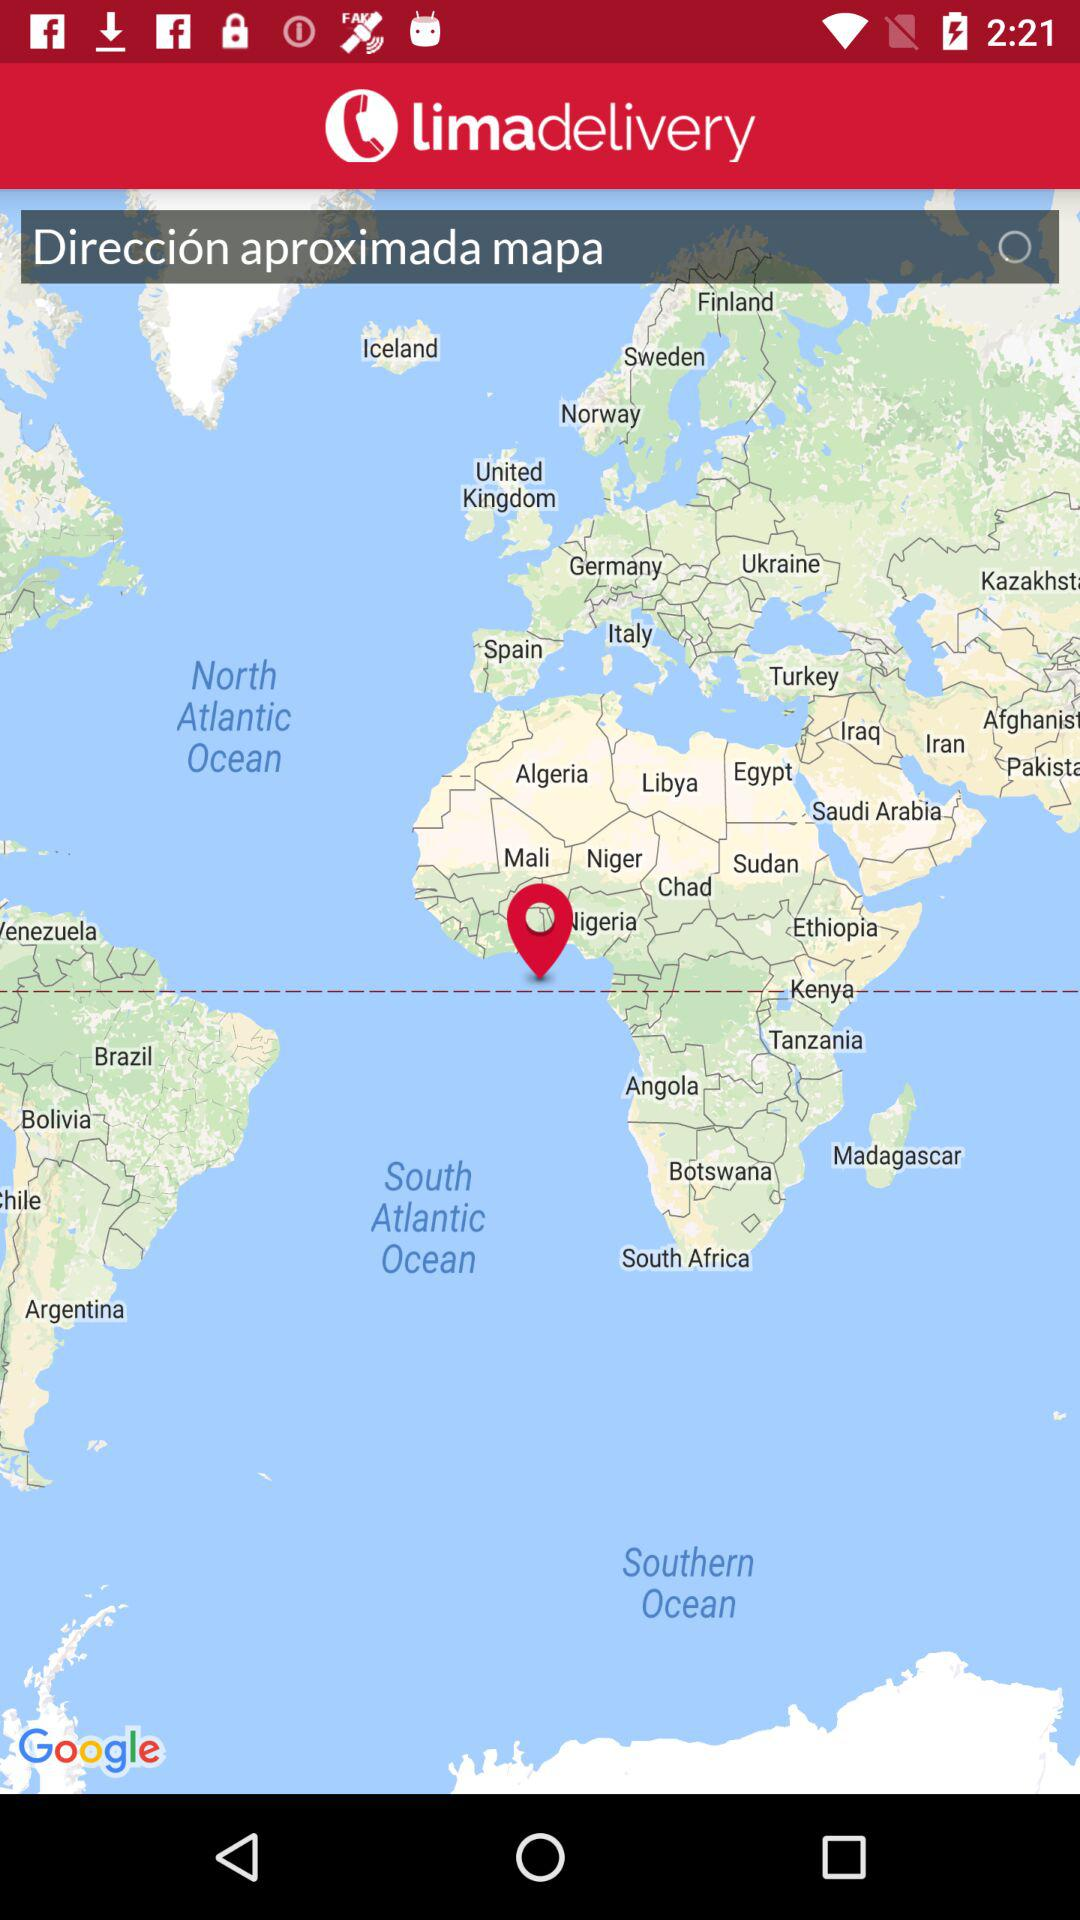When was the map copyrighted?
When the provided information is insufficient, respond with <no answer>. <no answer> 